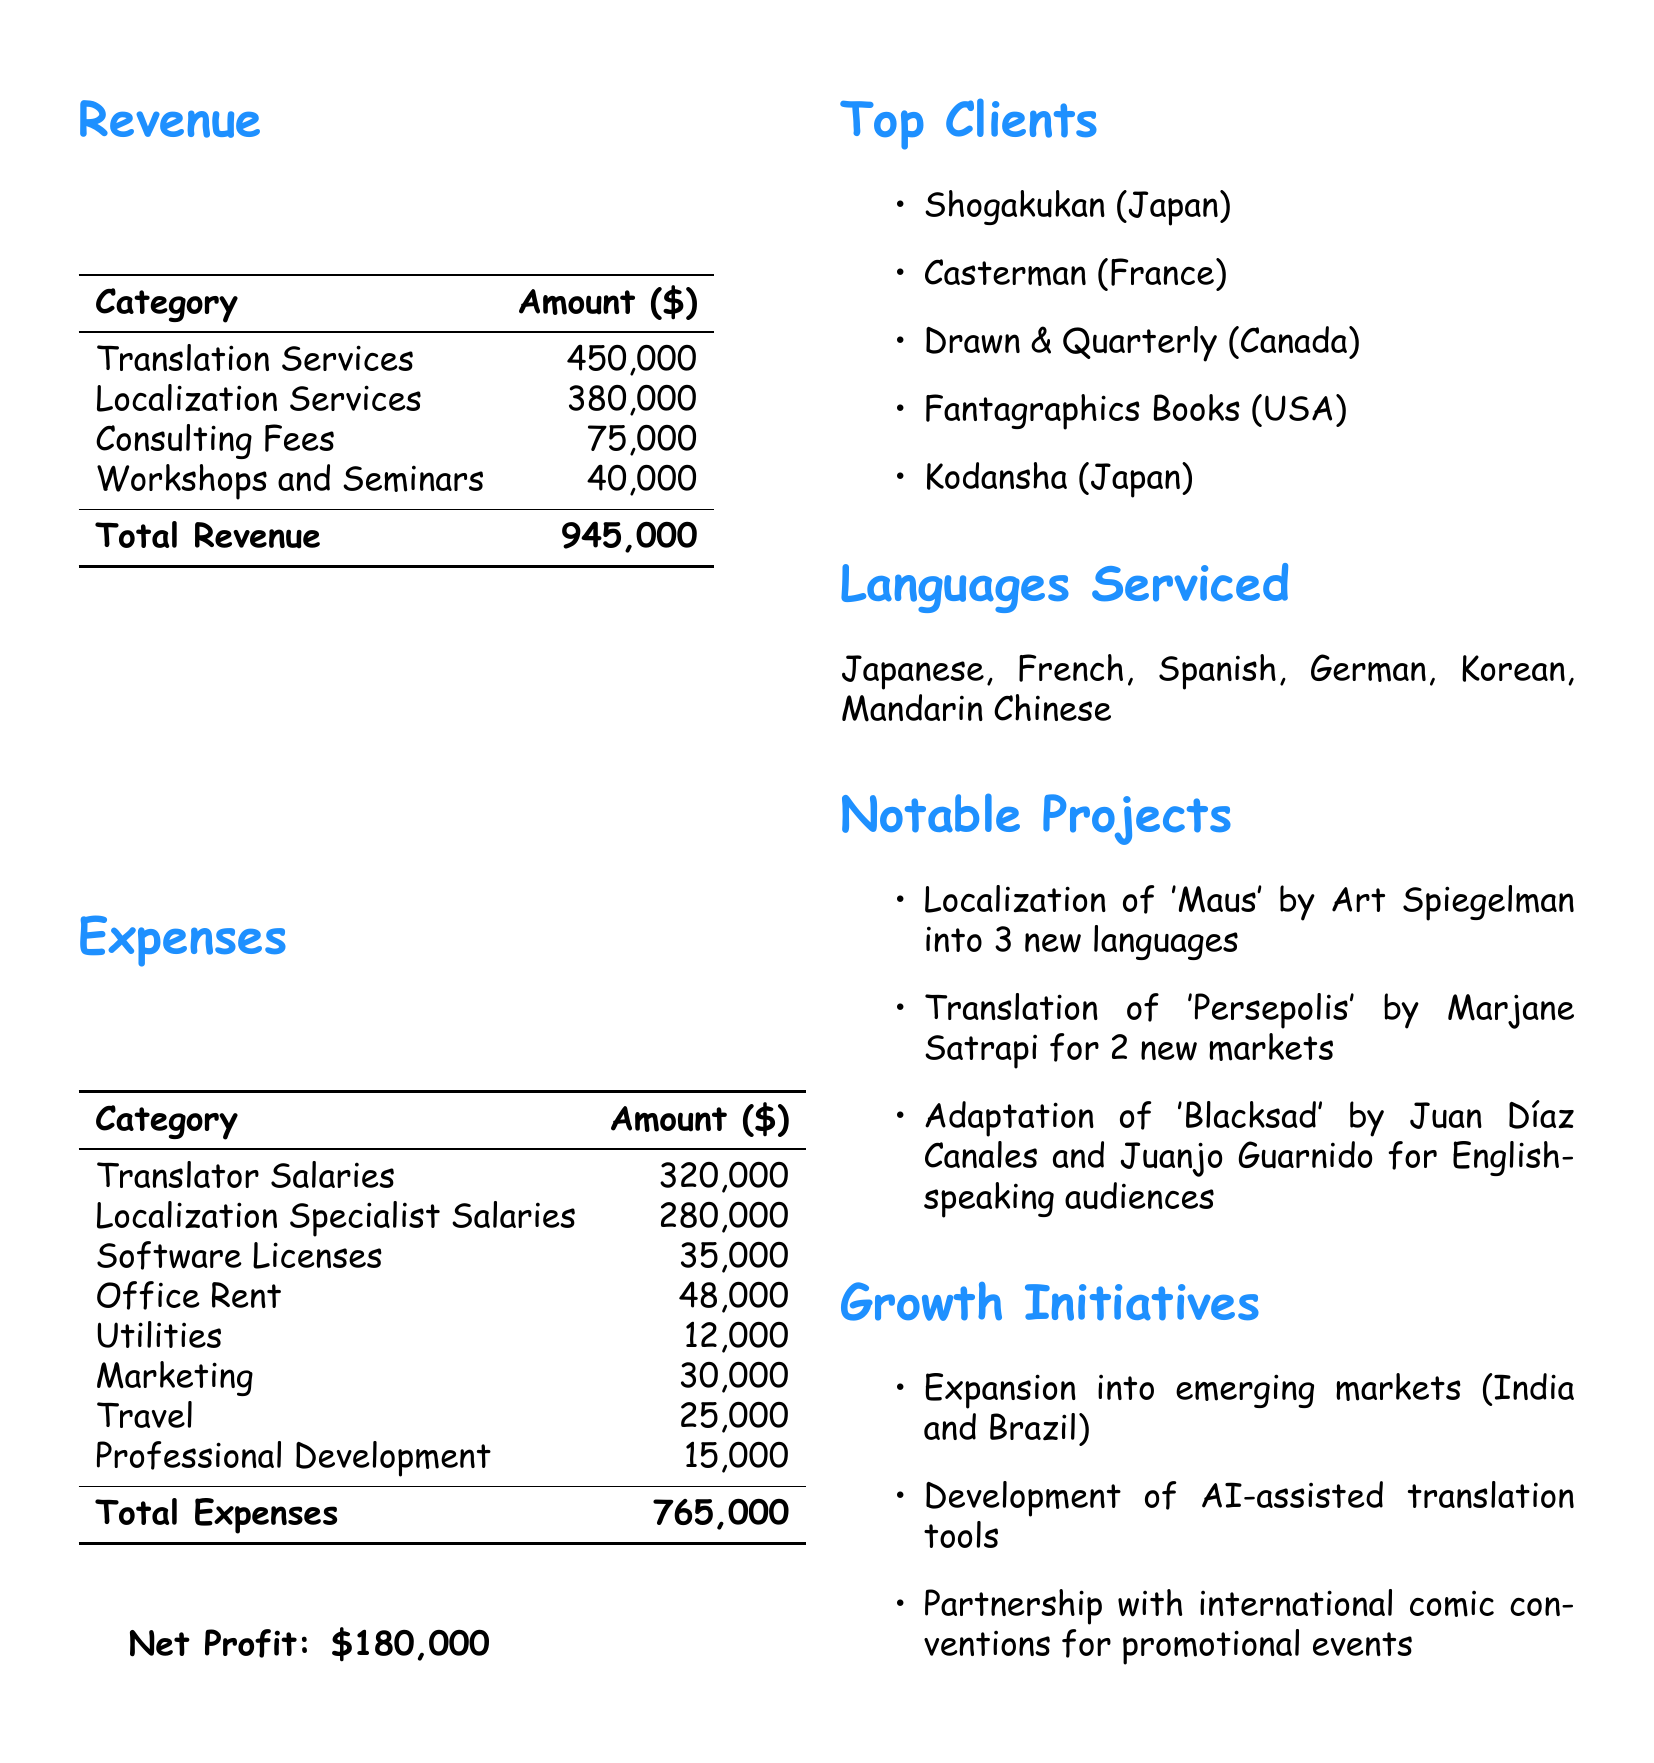What is the total revenue? The total revenue is the sum of all revenue sources in the document: 450000 + 380000 + 75000 + 40000 = 945000.
Answer: 945000 What is the total profit? The total profit is calculated by subtracting total expenses from total revenue: 945000 - 765000 = 180000.
Answer: 180000 Who is the top client from Japan? The top client from Japan listed in the document is Shogakukan.
Answer: Shogakukan How much was spent on translator salaries? The document states that translator salaries amounted to 320000.
Answer: 320000 Which languages are serviced? The document lists the languages serviced: Japanese, French, Spanish, German, Korean, Mandarin Chinese.
Answer: Japanese, French, Spanish, German, Korean, Mandarin Chinese What was the cost of software licenses? The expenses section mentions that software licenses cost 35000.
Answer: 35000 What notable project was translated into new markets? The document notes the translation of 'Persepolis' for 2 new markets as a notable project.
Answer: Translation of 'Persepolis' What is one growth initiative mentioned in the report? The document states a growth initiative is the expansion into emerging markets like India and Brazil.
Answer: Expansion into emerging markets How many total clients are mentioned? There are five top clients mentioned in the document.
Answer: Five What is the total amount spent on marketing? The document specifies that the marketing expense was 30000.
Answer: 30000 